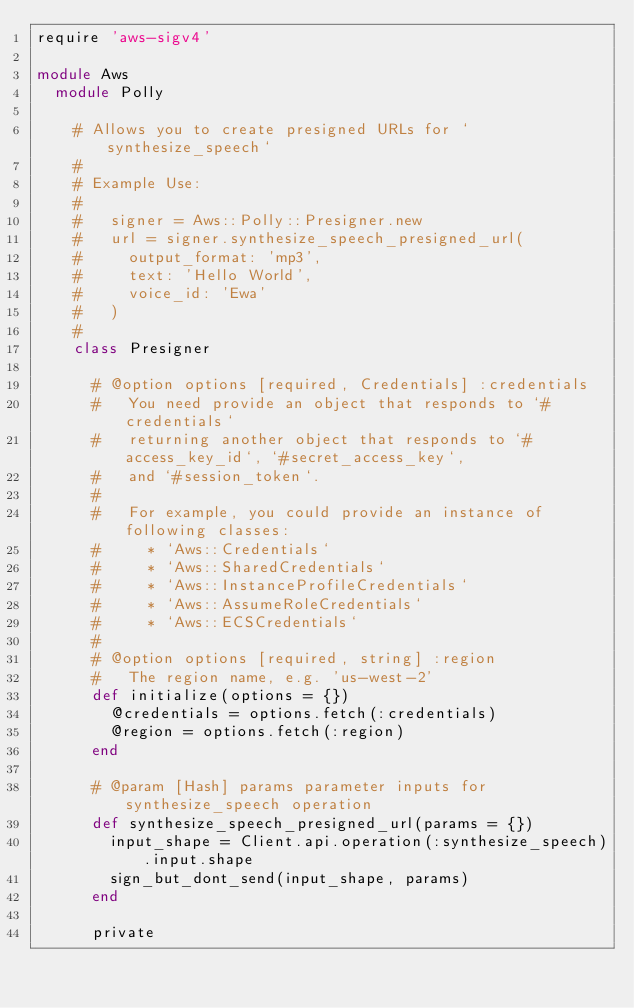<code> <loc_0><loc_0><loc_500><loc_500><_Ruby_>require 'aws-sigv4'

module Aws
  module Polly

    # Allows you to create presigned URLs for `synthesize_speech`
    #
    # Example Use:
    #
    #   signer = Aws::Polly::Presigner.new
    #   url = signer.synthesize_speech_presigned_url(
    #     output_format: 'mp3',
    #     text: 'Hello World',
    #     voice_id: 'Ewa'
    #   )
    #
    class Presigner

      # @option options [required, Credentials] :credentials
      #   You need provide an object that responds to `#credentials`
      #   returning another object that responds to `#access_key_id`, `#secret_access_key`,
      #   and `#session_token`.
      #
      #   For example, you could provide an instance of following classes:
      #     * `Aws::Credentials`
      #     * `Aws::SharedCredentials`
      #     * `Aws::InstanceProfileCredentials`
      #     * `Aws::AssumeRoleCredentials`
      #     * `Aws::ECSCredentials`
      #
      # @option options [required, string] :region
      #   The region name, e.g. 'us-west-2'
      def initialize(options = {})
        @credentials = options.fetch(:credentials)
        @region = options.fetch(:region)
      end

      # @param [Hash] params parameter inputs for synthesize_speech operation
      def synthesize_speech_presigned_url(params = {})
        input_shape = Client.api.operation(:synthesize_speech).input.shape
        sign_but_dont_send(input_shape, params)
      end

      private
</code> 